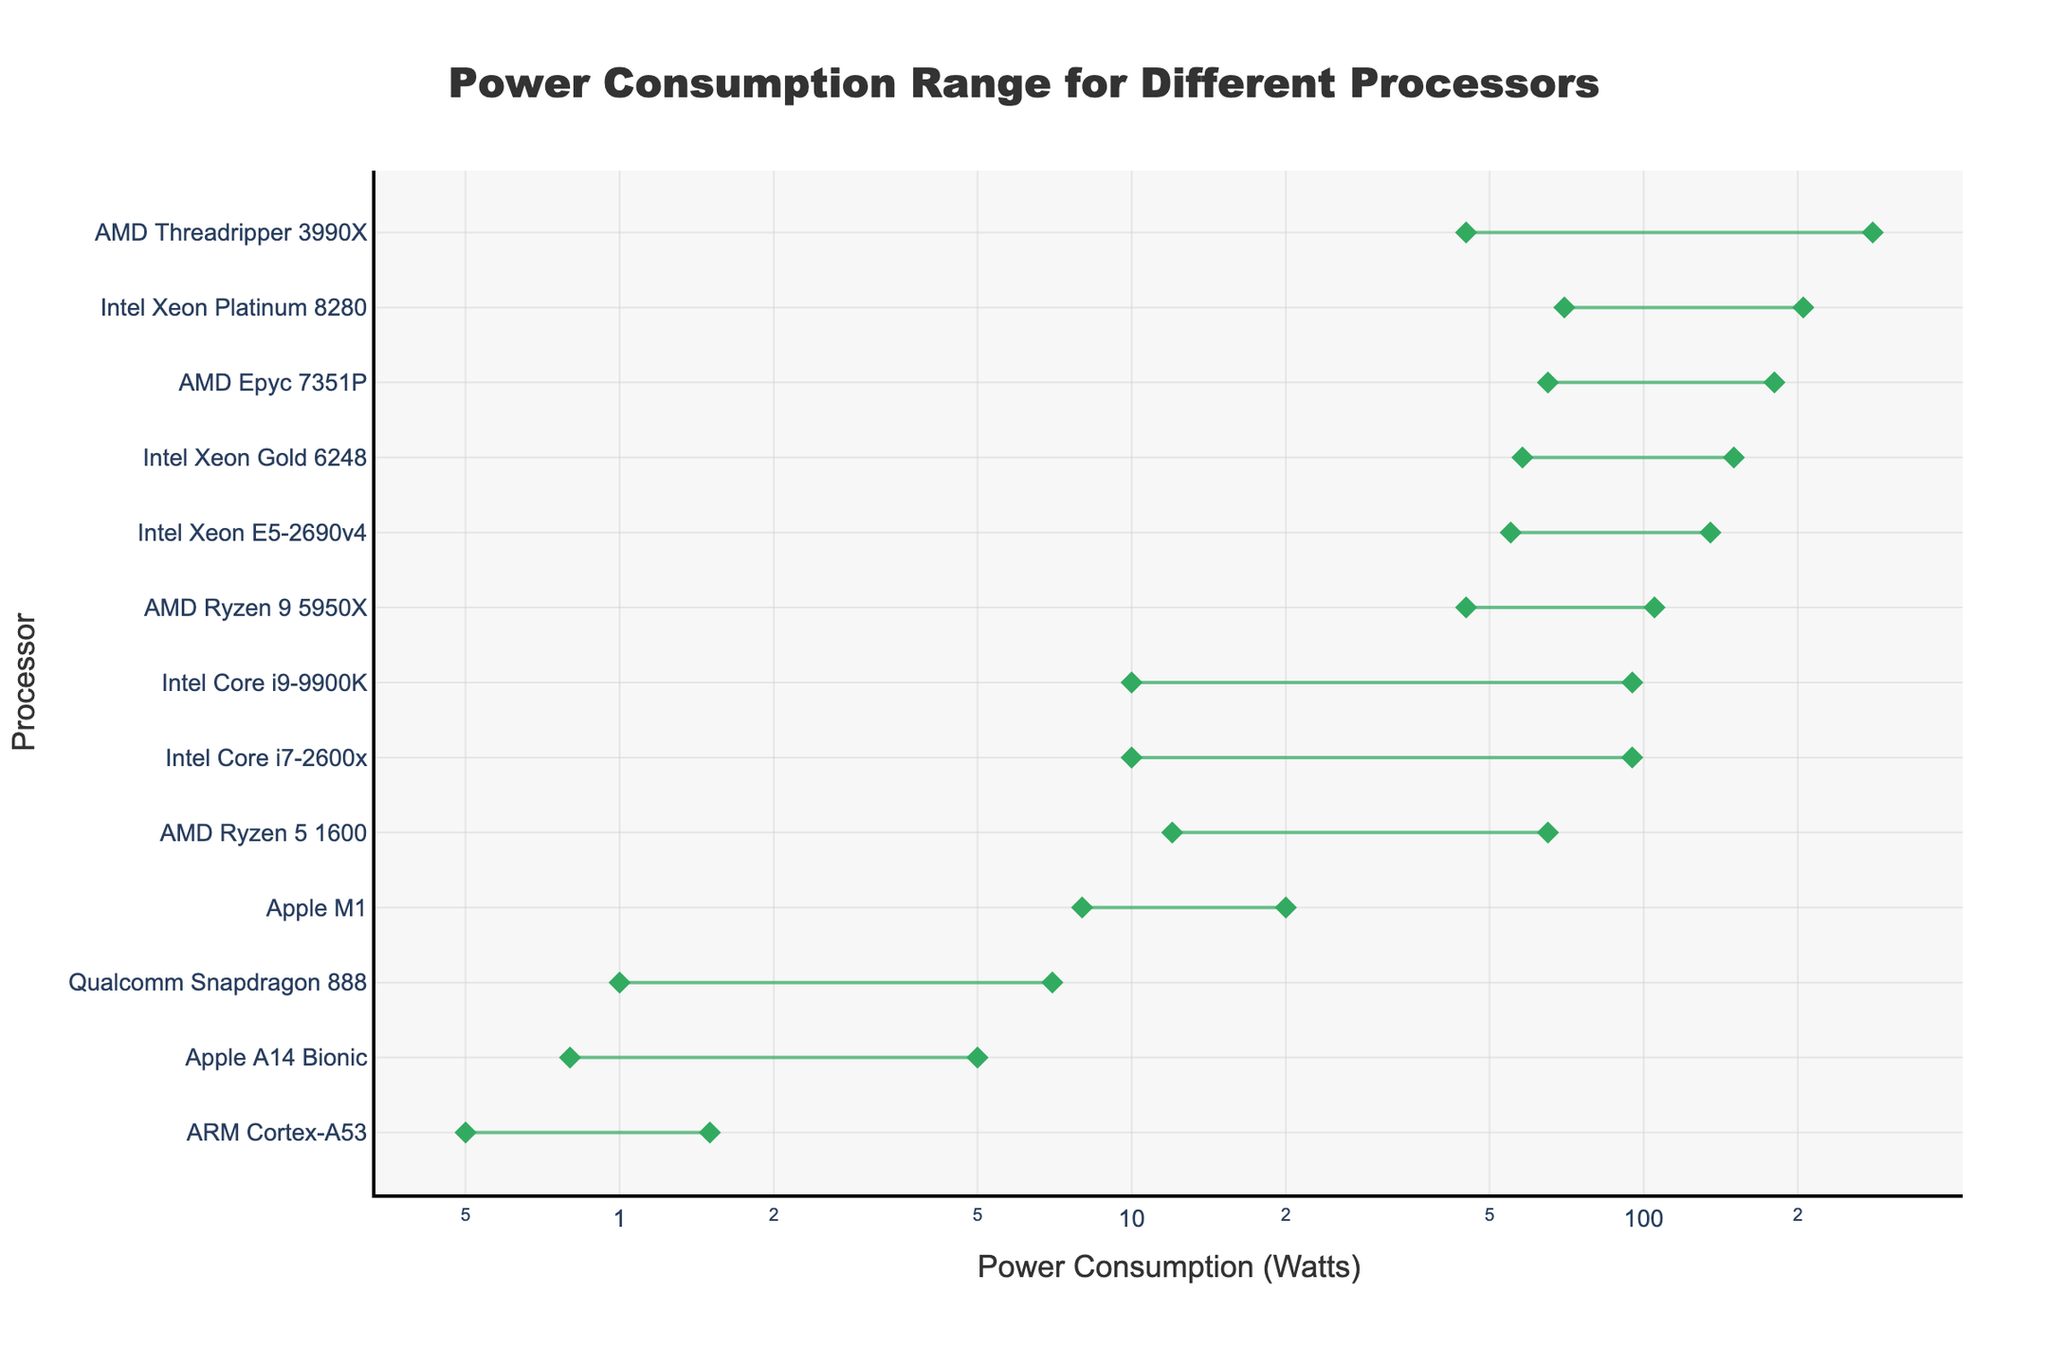What's the title of the figure? The title is displayed at the top of the figure in a large font. It is centrally aligned and reads "Power Consumption Range for Different Processors".
Answer: Power Consumption Range for Different Processors Which processor has the minimum power consumption? By looking at the leftmost point on the x-axis, we can see that the ARM Cortex-A53 processor has the minimum power consumption of 0.5 Watts.
Answer: ARM Cortex-A53 Which processor has the largest range in power consumption? To find the largest range, calculate the difference between the max and min power consumption for each processor. The AMD Threadripper 3990X has the largest range, from 45 Watts to 280 Watts, giving a total range of 235 Watts.
Answer: AMD Threadripper 3990X Which year saw the introduction of the most energy-efficient processor and what was it? By looking at the processors with the lowest minimum power consumption, we see the ARM Cortex-A53 (2014) and the Apple A14 Bionic (2020) with nearly similar low values, but both belong to different years. ARM Cortex-A53 has the lowest minimum consumption in 2014.
Answer: ARM Cortex-A53 (2014) What is the average maximum power consumption of the processors introduced in 2020? Identify the processors from 2020: Apple A14 Bionic (5 Watts), AMD Ryzen 9 5950X (105 Watts), Qualcomm Snapdragon 888 (7 Watts), AMD Threadripper 3990X (280 Watts), and Apple M1 (20 Watts). Sum their max power consumptions and divide by the number of processors: (5 + 105 + 7 + 280 + 20) / 5 = 83.4 Watts.
Answer: 83.4 Watts Which processor has the max power consumption closest to 100 Watts? The chart shows the AMD Ryzen 9 5950X, with a maximum power consumption of 105 Watts, which is closest to 100 Watts.
Answer: AMD Ryzen 9 5950X Compare the min power consumption between Intel Core i7-2600x and Intel Core i9-9900K. Which one is more power-efficient? Look at the min power consumption for both processors; both Intel Core i7-2600x and Intel Core i9-9900K have the same minimum power consumption of 10 Watts.
Answer: Neither, both have 10 Watts Which processor architectures have more than one processor represented in the figure? By observing the processors and their respective architectures, we see Sandy Bridge, ARMv8-A, Cascade Lake, and Zen are among the architectures with multiple processors: Intel Core i7-2600x (Sandy Bridge), ARM Cortex-A53, Qualcomm Snapdragon 888, Apple M1 (ARMv8-A), Intel Xeon Gold 6248, Intel Xeon Platinum 8280 (Cascade Lake), AMD Ryzen 5 1600, AMD Epyc 7351P, AMD Ryzen 9 5950X, AMD Threadripper 3990X (ZEN).
Answer: ARMv8-A, Cascade Lake, Zen How many processors have a max power consumption higher than 100 Watts? We count the number of processors with a max power consumption exceeding 100 Watts directly from the plot. The processors are: Intel Xeon E5-2690v4 (135 Watts), AMD Epyc 7351P (180 Watts), Intel Xeon Gold 6248 (150 Watts), AMD Threadripper 3990X (280 Watts), and Intel Xeon Platinum 8280 (205 Watts). There are five such processors.
Answer: 5 